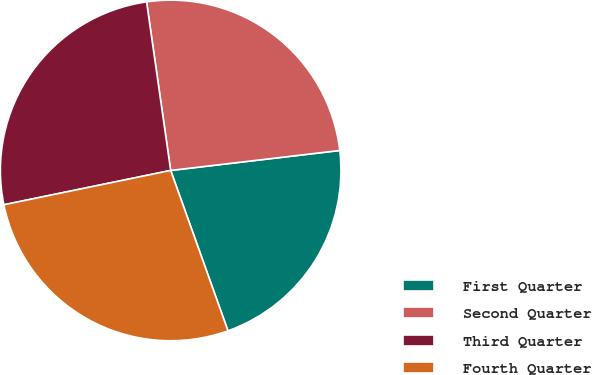<chart> <loc_0><loc_0><loc_500><loc_500><pie_chart><fcel>First Quarter<fcel>Second Quarter<fcel>Third Quarter<fcel>Fourth Quarter<nl><fcel>21.41%<fcel>25.39%<fcel>25.97%<fcel>27.23%<nl></chart> 